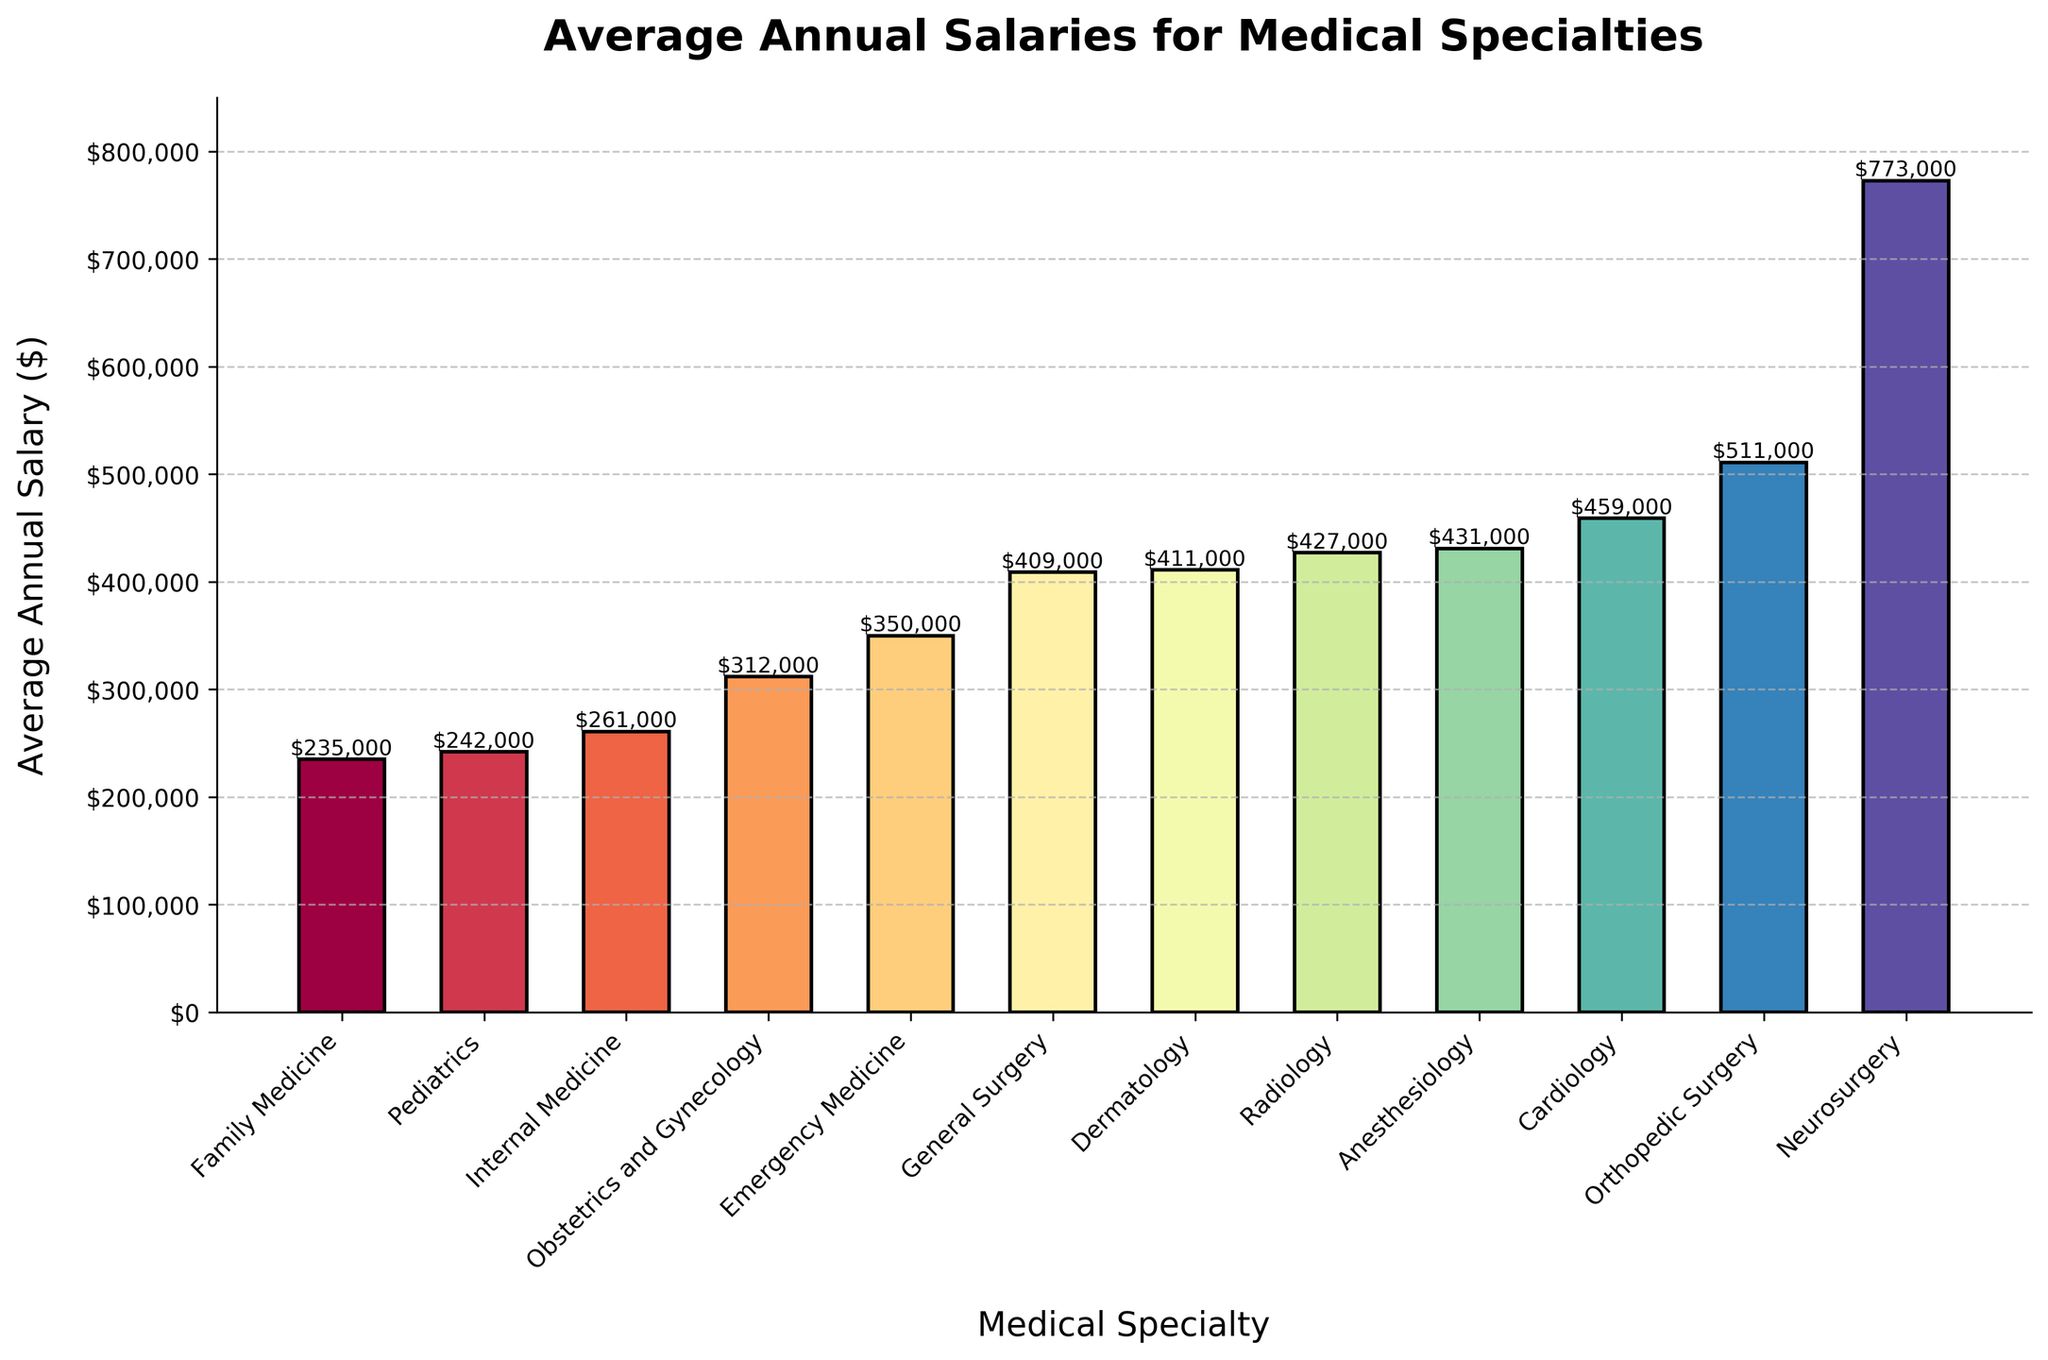What is the medical specialty with the highest average annual salary? The specialty with the highest bar in the chart corresponds to the highest average annual salary, which is Neurosurgery.
Answer: Neurosurgery Which medical specialty has a lower average annual salary: Pediatrics or Obstetrics and Gynecology? By comparing the heights of the bars labeled "Pediatrics" and "Obstetrics and Gynecology", it is clear that the bar for "Pediatrics" is shorter, indicating a lower average salary.
Answer: Pediatrics What is the approximate difference in annual salary between General Surgery and Dermatology? To find the difference, locate the bars for General Surgery and Dermatology, then subtract the height of General Surgery (409,000) from Dermatology (411,000).
Answer: $2,000 Which specialties have average annual salaries greater than $400,000? The bars whose heights exceed the $400,000 mark represent the specialties with higher salaries. These are Dermatology, Radiology, Anesthesiology, Cardiology, Orthopedic Surgery, and Neurosurgery.
Answer: Dermatology, Radiology, Anesthesiology, Cardiology, Orthopedic Surgery, Neurosurgery What is the combined average salary of Family Medicine, Pediatrics, and Internal Medicine? Sum the values for these three specialties: Family Medicine ($235,000) + Pediatrics ($242,000) + Internal Medicine ($261,000) = $738,000.
Answer: $738,000 How does the average annual salary of Emergency Medicine compare to that of Cardiology? Comparing the height of the bars for Emergency Medicine ($350,000) and Cardiology ($459,000) shows that Emergency Medicine salary is lower.
Answer: Lower Which specialty has the second highest average annual salary, and what is the salary? Identify the tallest bar (Neurosurgery) and then find the second tallest bar, which corresponds to Orthopedic Surgery, with a salary of $511,000.
Answer: Orthopedic Surgery, $511,000 What is the range in salaries from the lowest to the highest paid specialties? The range is calculated by subtracting the lowest salary (Family Medicine: $235,000) from the highest salary (Neurosurgery: $773,000). Range = $773,000 - $235,000.
Answer: $538,000 What is the visual trend in the average annual salaries as we move from Family Medicine to Neurosurgery on the x-axis? The bars progressively increase in height from left (Family Medicine) to right (Neurosurgery) indicating an upward trend in salaries.
Answer: Upward trend 